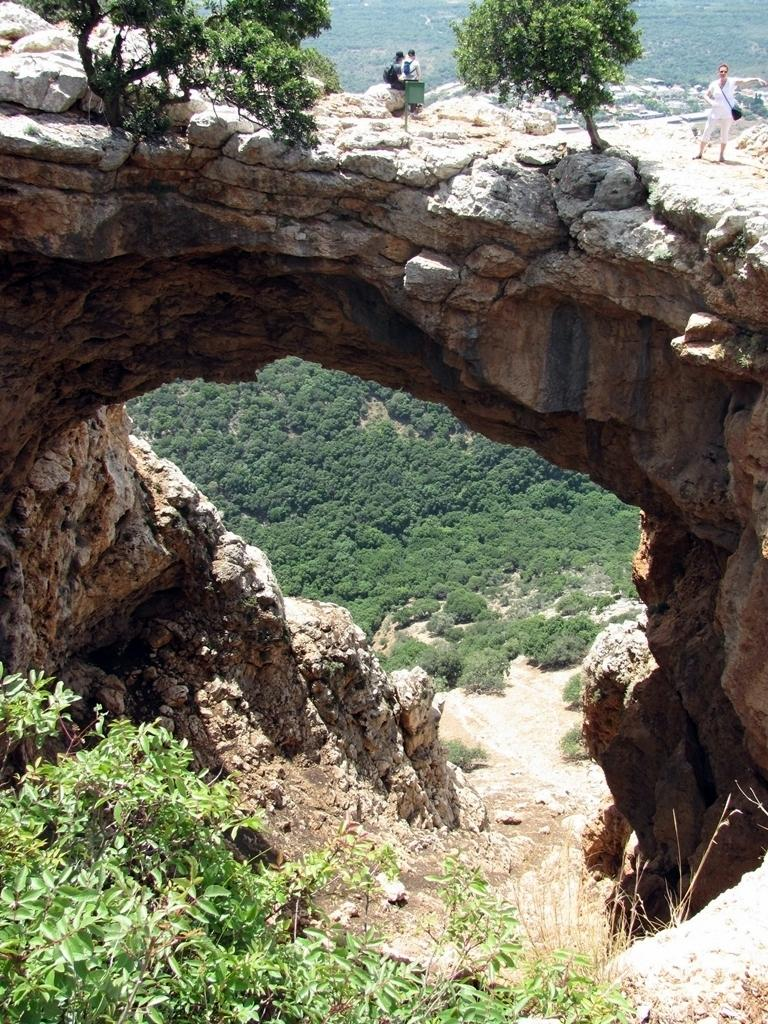What type of view is provided in the image? The image is an aerial view. What type of natural features can be seen in the image? There are trees and rocks visible in the image. Are there any people visible in the image? Yes, there are persons visible in the image. What is the harmony like between the volcano and the trees in the image? There is no volcano present in the image, so it is not possible to determine the harmony between a volcano and the trees. 